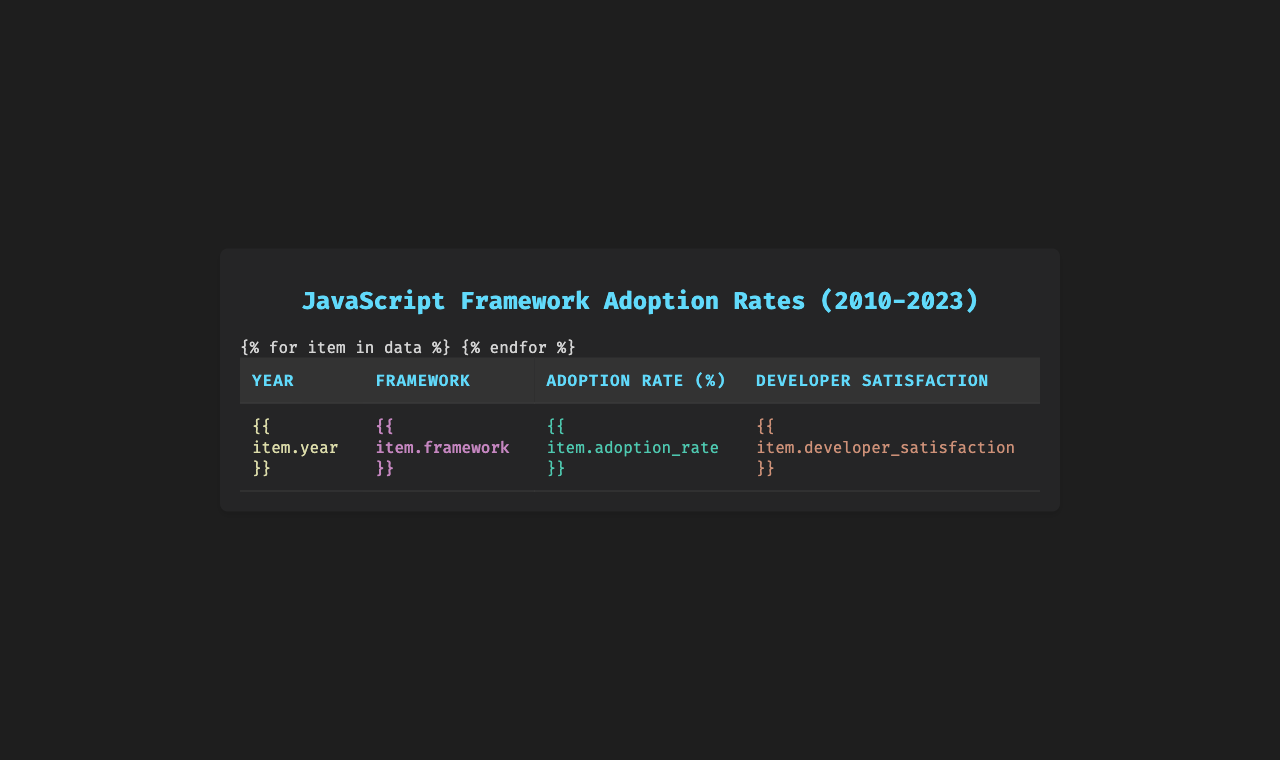What was the adoption rate of React in 2020? By looking at the row for the year 2020 under the framework "React," the adoption rate is directly listed as 68.9% in the table.
Answer: 68.9% Which framework had the highest developer satisfaction in 2023? In 2023, the framework listed is "Astro," which has a developer satisfaction score of 9.2. Checking other frameworks for that year, none exceed this value.
Answer: Astro What is the adoption rate difference between jQuery in 2010 and React in 2017? In 2010, jQuery had an adoption rate of 78.1%, while React in 2017 had an adoption rate of 37.8%. The difference is calculated as 78.1 - 37.8 = 40.3%.
Answer: 40.3% What was the average adoption rate of Vue.js across the years it appears? Vue.js appears in 2015 with 2.1% and in 2018 with 15.2%. The sum is 2.1 + 15.2 = 17.3%, and there are 2 data points, so the average is 17.3 / 2 = 8.65%.
Answer: 8.65% Did the adoption rate of AngularJS surpass that of Backbone.js in their respective years? AngularJS had an adoption rate of 31.5% in 2013, while Backbone.js had 12.3% in 2011. Therefore, AngularJS did surpass Backbone.js during its adoption period.
Answer: Yes Which framework saw the greatest increase in adoption rate from one year to the next, between 2017 and 2020? In 2017, React’s adoption rate was 37.8%, which increased to 68.9% in 2020. The increase is 68.9 - 37.8 = 31.1%. To confirm it's the greatest, check other frameworks for lesser increases, but this is the largest.
Answer: React What was the trend of developer satisfaction from 2015 to 2022? The developer satisfaction scores from 2015 (8.7), 2018 (9.1), 2021 (8.9), and 2022 (8.6) show an overall increase followed by a decrease in later years. Specifically, there is an increase from 8.7 to 9.1, then a decrease to 8.9 and finally to 8.6.
Answer: Overall increase then decrease What is the total adoption rate for all the frameworks listed in 2021? The table lists Next.js in 2021 with an adoption rate of 11.2%. As there is only one framework for that year, the total adoption rate is the same: 11.2%.
Answer: 11.2% Does any framework in 2022 have a higher adoption rate than any framework in 2011? In 2011, Backbone.js had an adoption rate of 12.3%. The framework in 2022 (Remix) had an adoption rate of 2.8%, which is lower than 12.3%. Thus, no 2022 framework exceeds the 2011 rate.
Answer: No What framework had the lowest adoption rate in 2015 and what was that rate? The table shows that Vue.js had the lowest adoption rate in 2015 at 2.1%. There are no other frameworks listed for that year with a lower adoption rate.
Answer: Vue.js with 2.1% 